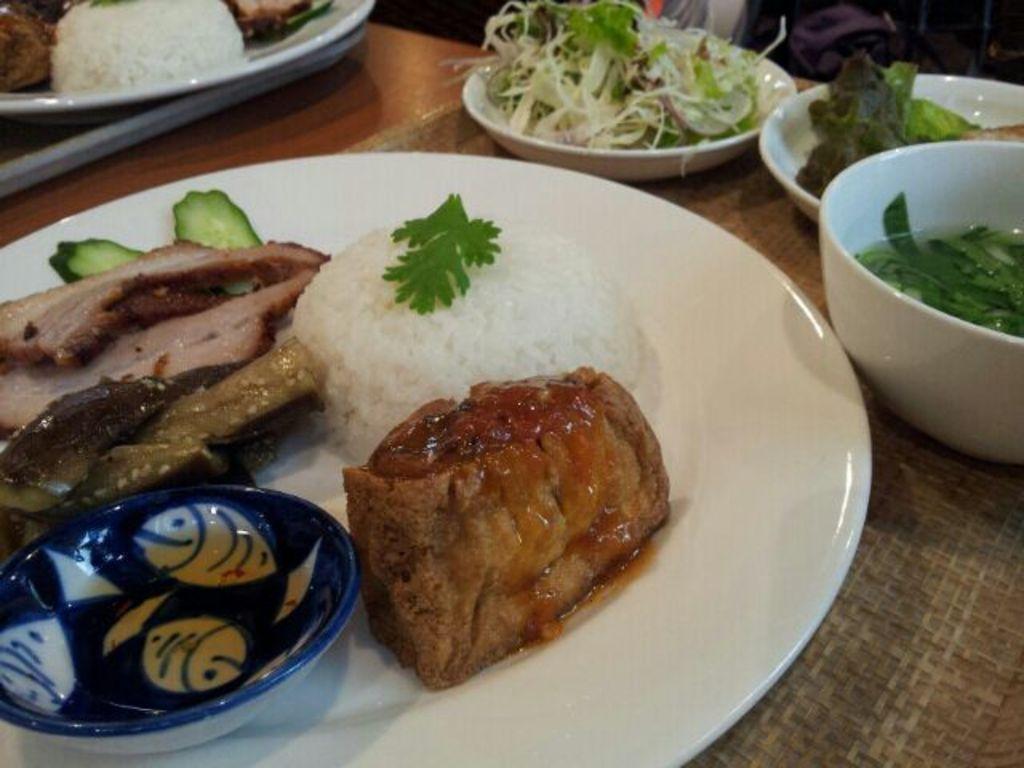Could you give a brief overview of what you see in this image? In this image I can see few food items and they are in brown, white and green color and the food items are in the plates and the plates are in white color. 